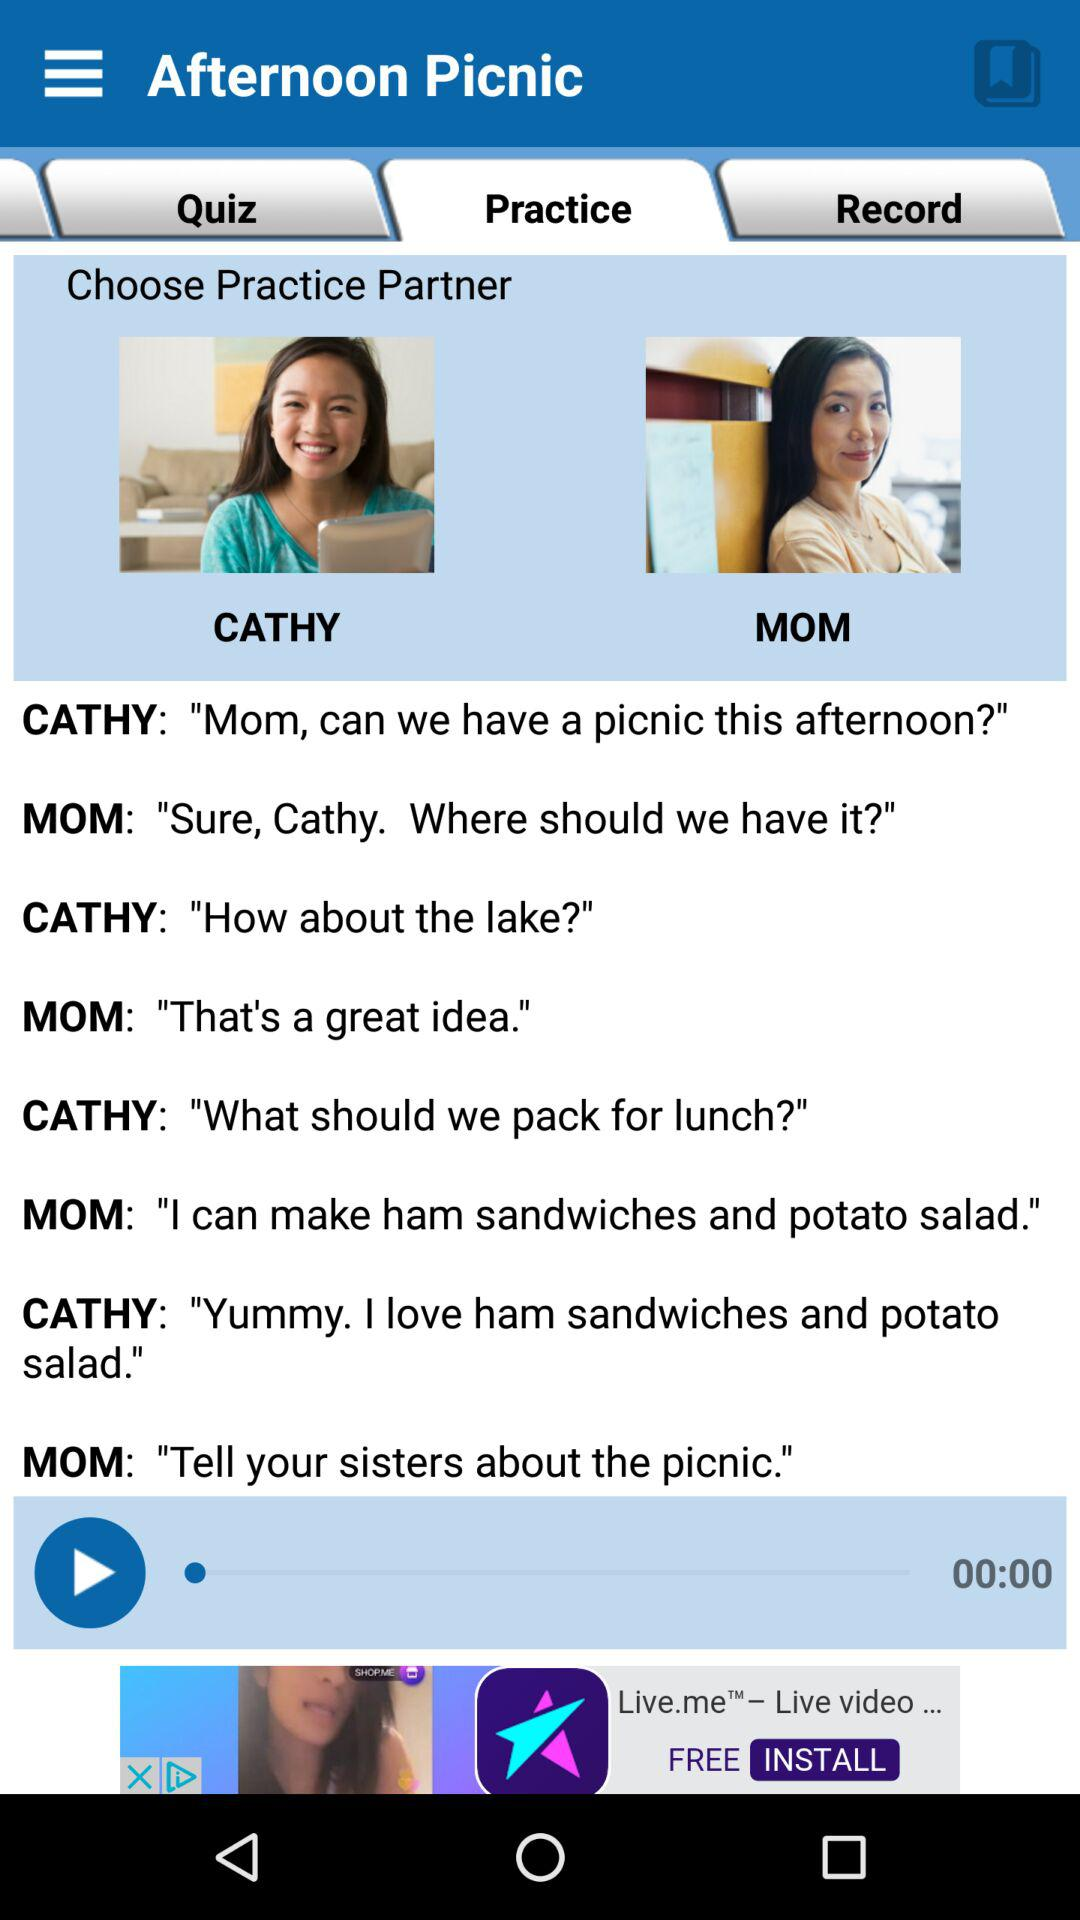Which tab is selected? The selected tab is "Practice". 